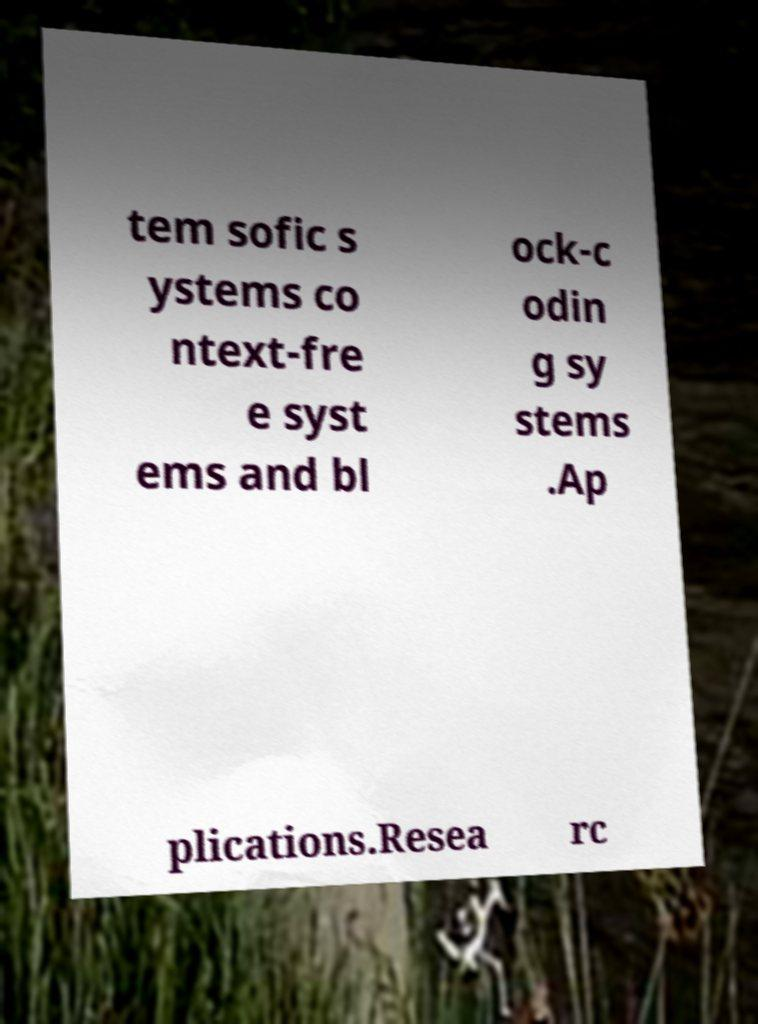There's text embedded in this image that I need extracted. Can you transcribe it verbatim? tem sofic s ystems co ntext-fre e syst ems and bl ock-c odin g sy stems .Ap plications.Resea rc 